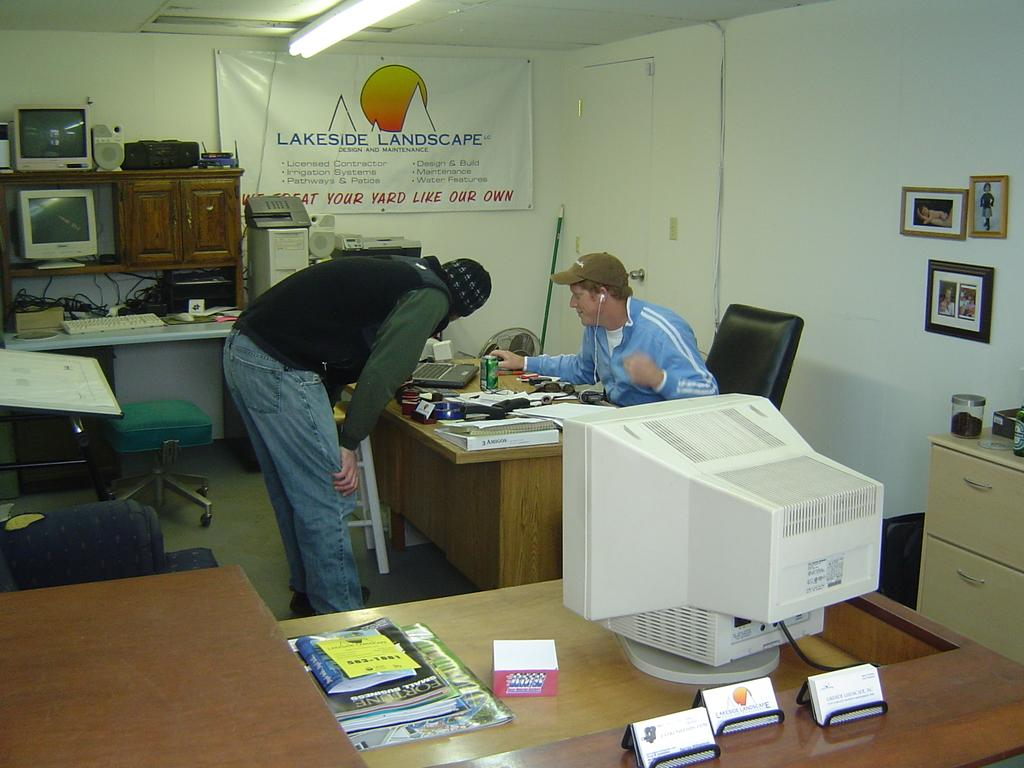What is the man in the image doing? There is a man sitting on a chair in the image. What is the other man in the image doing? There is another man standing on a table in the image. What objects can be seen related to work or study in the image? There are papers and a laptop visible in the image. What type of container is present in the image? There is a can in the image. What type of light can be seen emanating from the can in the image? There is no light emanating from the can in the image. What type of ray is being emitted by the laptop in the image? There is no ray being emitted by the laptop in the image. 